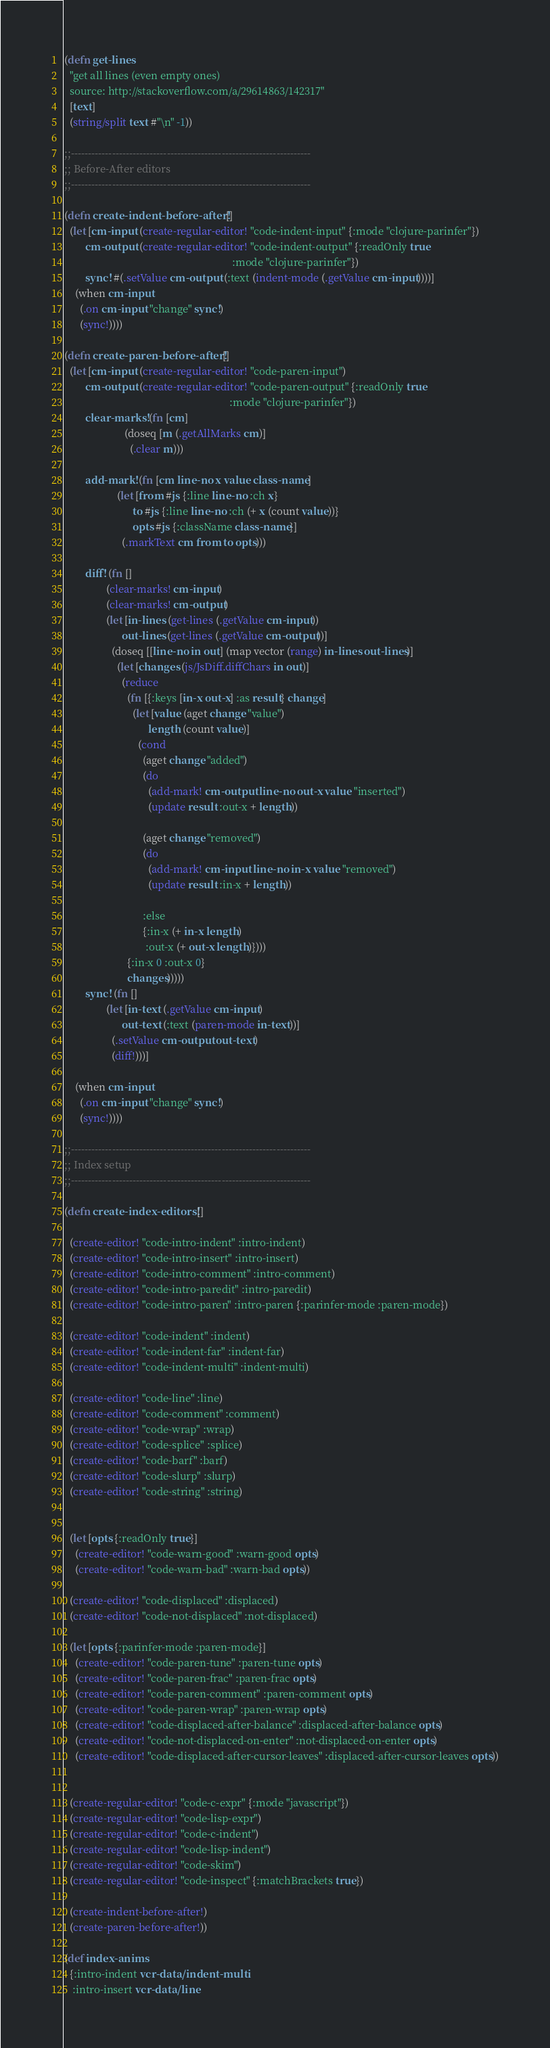<code> <loc_0><loc_0><loc_500><loc_500><_Clojure_>(defn get-lines
  "get all lines (even empty ones)
  source: http://stackoverflow.com/a/29614863/142317"
  [text]
  (string/split text #"\n" -1))

;;----------------------------------------------------------------------
;; Before-After editors
;;----------------------------------------------------------------------

(defn create-indent-before-after! []
  (let [cm-input (create-regular-editor! "code-indent-input" {:mode "clojure-parinfer"})
        cm-output (create-regular-editor! "code-indent-output" {:readOnly true
                                                                :mode "clojure-parinfer"})
        sync! #(.setValue cm-output (:text (indent-mode (.getValue cm-input))))]
    (when cm-input
      (.on cm-input "change" sync!)
      (sync!))))

(defn create-paren-before-after! []
  (let [cm-input (create-regular-editor! "code-paren-input")
        cm-output (create-regular-editor! "code-paren-output" {:readOnly true
                                                               :mode "clojure-parinfer"})
        clear-marks! (fn [cm]
                       (doseq [m (.getAllMarks cm)]
                         (.clear m)))

        add-mark! (fn [cm line-no x value class-name]
                    (let [from #js {:line line-no :ch x}
                          to #js {:line line-no :ch (+ x (count value))}
                          opts #js {:className class-name}]
                      (.markText cm from to opts)))

        diff! (fn []
                (clear-marks! cm-input)
                (clear-marks! cm-output)
                (let [in-lines (get-lines (.getValue cm-input))
                      out-lines (get-lines (.getValue cm-output))]
                  (doseq [[line-no in out] (map vector (range) in-lines out-lines)]
                    (let [changes (js/JsDiff.diffChars in out)]
                      (reduce
                        (fn [{:keys [in-x out-x] :as result} change]
                          (let [value (aget change "value")
                                length (count value)]
                            (cond
                              (aget change "added")
                              (do
                                (add-mark! cm-output line-no out-x value "inserted")
                                (update result :out-x + length))

                              (aget change "removed")
                              (do
                                (add-mark! cm-input line-no in-x value "removed")
                                (update result :in-x + length))

                              :else
                              {:in-x (+ in-x length)
                               :out-x (+ out-x length)})))
                        {:in-x 0 :out-x 0}
                        changes)))))
        sync! (fn []
                (let [in-text (.getValue cm-input)
                      out-text (:text (paren-mode in-text))]
                  (.setValue cm-output out-text)
                  (diff!)))]

    (when cm-input
      (.on cm-input "change" sync!)
      (sync!))))

;;----------------------------------------------------------------------
;; Index setup
;;----------------------------------------------------------------------

(defn create-index-editors! []

  (create-editor! "code-intro-indent" :intro-indent)
  (create-editor! "code-intro-insert" :intro-insert)
  (create-editor! "code-intro-comment" :intro-comment)
  (create-editor! "code-intro-paredit" :intro-paredit)
  (create-editor! "code-intro-paren" :intro-paren {:parinfer-mode :paren-mode})

  (create-editor! "code-indent" :indent)
  (create-editor! "code-indent-far" :indent-far)
  (create-editor! "code-indent-multi" :indent-multi)

  (create-editor! "code-line" :line)
  (create-editor! "code-comment" :comment)
  (create-editor! "code-wrap" :wrap)
  (create-editor! "code-splice" :splice)
  (create-editor! "code-barf" :barf)
  (create-editor! "code-slurp" :slurp)
  (create-editor! "code-string" :string)


  (let [opts {:readOnly true}]
    (create-editor! "code-warn-good" :warn-good opts)
    (create-editor! "code-warn-bad" :warn-bad opts))

  (create-editor! "code-displaced" :displaced)
  (create-editor! "code-not-displaced" :not-displaced)

  (let [opts {:parinfer-mode :paren-mode}]
    (create-editor! "code-paren-tune" :paren-tune opts)
    (create-editor! "code-paren-frac" :paren-frac opts)
    (create-editor! "code-paren-comment" :paren-comment opts)
    (create-editor! "code-paren-wrap" :paren-wrap opts)
    (create-editor! "code-displaced-after-balance" :displaced-after-balance opts)
    (create-editor! "code-not-displaced-on-enter" :not-displaced-on-enter opts)
    (create-editor! "code-displaced-after-cursor-leaves" :displaced-after-cursor-leaves opts))


  (create-regular-editor! "code-c-expr" {:mode "javascript"})
  (create-regular-editor! "code-lisp-expr")
  (create-regular-editor! "code-c-indent")
  (create-regular-editor! "code-lisp-indent")
  (create-regular-editor! "code-skim")
  (create-regular-editor! "code-inspect" {:matchBrackets true})

  (create-indent-before-after!)
  (create-paren-before-after!))

(def index-anims
  {:intro-indent vcr-data/indent-multi
   :intro-insert vcr-data/line</code> 